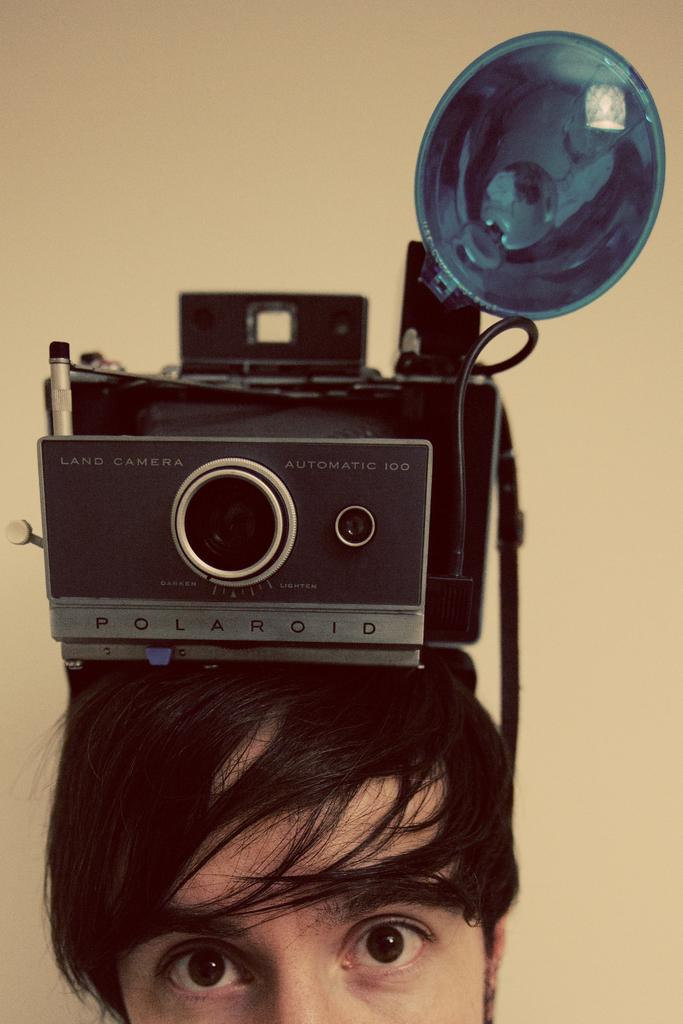What is the unusual object on the person's head in the image? There is a camera on a person's head in the image. Where is the camera located in relation to the person? The camera is visible in the bottom of the image. What can be seen in the background of the image? There is a wall in the background of the image. What type of straw is being used to write on the paper in the image? There is no straw or paper present in the image; it only features a person with a camera on their head and a wall in the background. 